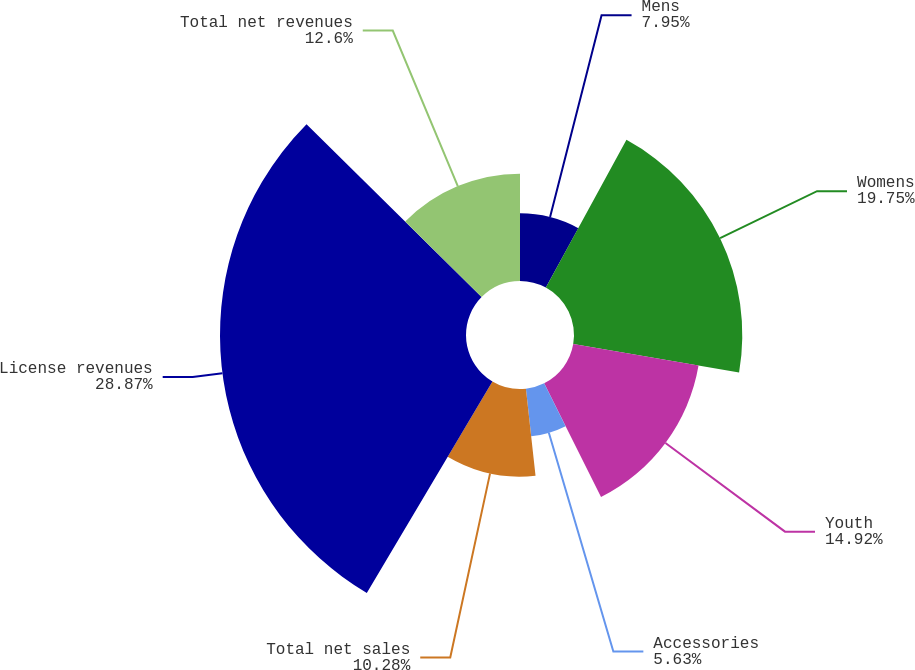Convert chart to OTSL. <chart><loc_0><loc_0><loc_500><loc_500><pie_chart><fcel>Mens<fcel>Womens<fcel>Youth<fcel>Accessories<fcel>Total net sales<fcel>License revenues<fcel>Total net revenues<nl><fcel>7.95%<fcel>19.75%<fcel>14.92%<fcel>5.63%<fcel>10.28%<fcel>28.87%<fcel>12.6%<nl></chart> 